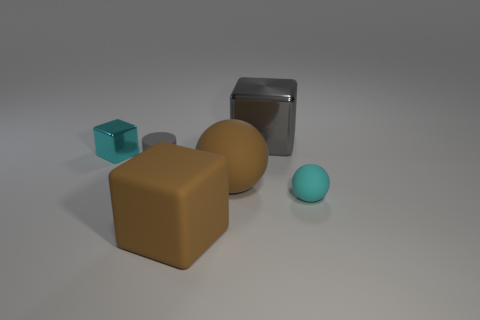The thing that is both behind the large sphere and on the right side of the small gray object is made of what material?
Provide a succinct answer. Metal. Is there a big thing in front of the small rubber thing behind the small cyan rubber sphere that is in front of the cyan metallic thing?
Provide a succinct answer. Yes. The metal cube that is the same color as the tiny ball is what size?
Give a very brief answer. Small. There is a big brown sphere; are there any large blocks behind it?
Offer a very short reply. Yes. How many other things are the same shape as the small gray thing?
Offer a terse response. 0. What color is the matte thing that is the same size as the matte cube?
Offer a very short reply. Brown. Is the number of gray shiny blocks left of the gray cylinder less than the number of brown blocks in front of the cyan metal cube?
Provide a succinct answer. Yes. There is a small cyan object that is on the left side of the large block in front of the tiny cyan sphere; what number of gray matte things are left of it?
Give a very brief answer. 0. The cyan object that is the same shape as the big gray metallic thing is what size?
Offer a terse response. Small. Are there fewer large brown rubber things that are to the right of the large shiny cube than cyan rubber things?
Offer a very short reply. Yes. 